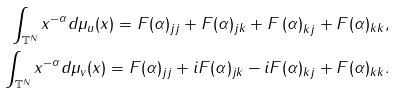Convert formula to latex. <formula><loc_0><loc_0><loc_500><loc_500>\int _ { \mathbb { T } ^ { N } } x ^ { - \alpha } d \mu _ { u } ( x ) = F ( \alpha ) _ { j j } + F ( \alpha ) _ { j k } + F \left ( \alpha \right ) _ { k j } + F ( \alpha ) _ { k k } , \\ \int _ { \mathbb { T } ^ { N } } x ^ { - \alpha } d \mu _ { v } ( x ) = F ( \alpha ) _ { j j } + i F ( \alpha ) _ { j k } - i F ( \alpha ) _ { k j } + F ( \alpha ) _ { k k } .</formula> 